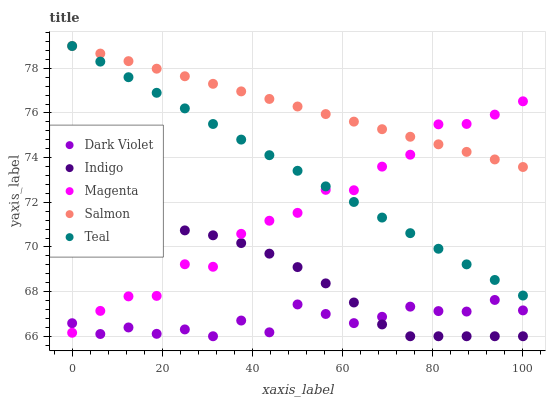Does Dark Violet have the minimum area under the curve?
Answer yes or no. Yes. Does Salmon have the maximum area under the curve?
Answer yes or no. Yes. Does Magenta have the minimum area under the curve?
Answer yes or no. No. Does Magenta have the maximum area under the curve?
Answer yes or no. No. Is Teal the smoothest?
Answer yes or no. Yes. Is Magenta the roughest?
Answer yes or no. Yes. Is Indigo the smoothest?
Answer yes or no. No. Is Indigo the roughest?
Answer yes or no. No. Does Indigo have the lowest value?
Answer yes or no. Yes. Does Magenta have the lowest value?
Answer yes or no. No. Does Teal have the highest value?
Answer yes or no. Yes. Does Magenta have the highest value?
Answer yes or no. No. Is Indigo less than Salmon?
Answer yes or no. Yes. Is Teal greater than Indigo?
Answer yes or no. Yes. Does Dark Violet intersect Magenta?
Answer yes or no. Yes. Is Dark Violet less than Magenta?
Answer yes or no. No. Is Dark Violet greater than Magenta?
Answer yes or no. No. Does Indigo intersect Salmon?
Answer yes or no. No. 